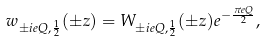<formula> <loc_0><loc_0><loc_500><loc_500>w _ { \pm i e Q , \frac { 1 } { 2 } } ( \pm z ) = W _ { \pm i e Q , \frac { 1 } { 2 } } ( \pm z ) e ^ { - \frac { \pi e Q } { 2 } } ,</formula> 